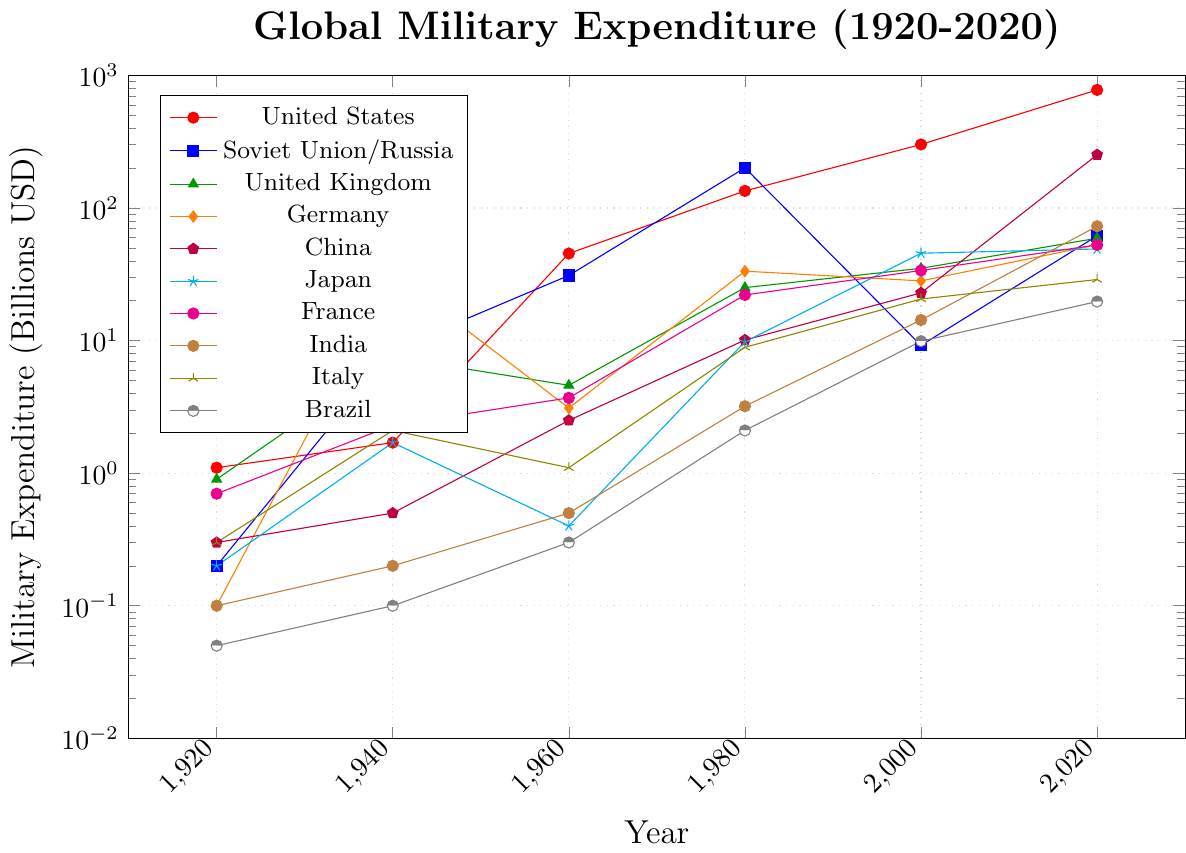What country had the highest military expenditure in 2020? Looking at the end points of all the lines, the United States had the highest expenditure in 2020.
Answer: United States When comparing the Soviet Union/Russia and China, which country had a higher military expenditure in 1980? Referring to the coordinates for 1980, the Soviet Union/Russia had a military expenditure of 201 billion USD, whereas China had 10.1 billion USD, making Soviet Union/Russia higher.
Answer: Soviet Union/Russia What is the total military expenditure for the United States across all the given years? Adding the expenditures: 1.1 (1920) + 1.7 (1940) + 45.4 (1960) + 134.6 (1980) + 301.7 (2000) + 778.2 (2020) = 1,262.7 billion USD.
Answer: 1,262.7 billion USD Which country showed the largest increase in military expenditure from 2000 to 2020? By subtracting the 2000 values from the 2020 values: United States (778.2 - 301.7), Soviet Union/Russia (61.7 - 9.2), United Kingdom (59.2 - 35.1), Germany (52.8 - 28.2), China (252.3 - 22.9), Japan (49.1 - 45.6), France (52.7 - 33.8), India (72.9 - 14.3), Italy (28.9 - 20.6), Brazil (19.7 - 9.9), the largest increase is seen in China with an increase of 229.4 billion USD.
Answer: China How does the military expenditure of France in 2020 compare to that of Germany in 1940? France in 2020 had an expenditure of 52.7 billion USD and Germany in 1940 had 32.0 billion USD. France's expenditure in 2020 was higher.
Answer: France What was the military expenditure trend for Italy from 1920 to 2020? Referring to the coordinates for Italy: 0.3 (1920), 2.1 (1940), 1.1 (1960), 8.9 (1980), 20.6 (2000), 28.9 (2020). Italy's expenditure generally increased over this period, despite a drop from 1940 to 1960.
Answer: Increased generally In 1940, which two countries had the closest military expenditure figures? Referring to the values in 1940: United States (1.7), Soviet Union/Russia (8.5), United Kingdom (7.5), Germany (32.0), China (0.5), Japan (1.7), France (2.3), India (0.2), Italy (2.1), Brazil (0.1), the closest values are for Japan and United States, both at 1.7 billion USD.
Answer: United States and Japan By what factor did the United States' military expenditure increase from 1920 to 2020? Dividing the 2020 value by the 1920 value: 778.2 / 1.1 ≈ 707.64. The military expenditure increased by approximately 707.64 times.
Answer: ~707.64 Which country had the lowest military expenditure in 1920? Referring to the coordinates for 1920, Brazil had the lowest military expenditure of 0.05 billion USD.
Answer: Brazil 